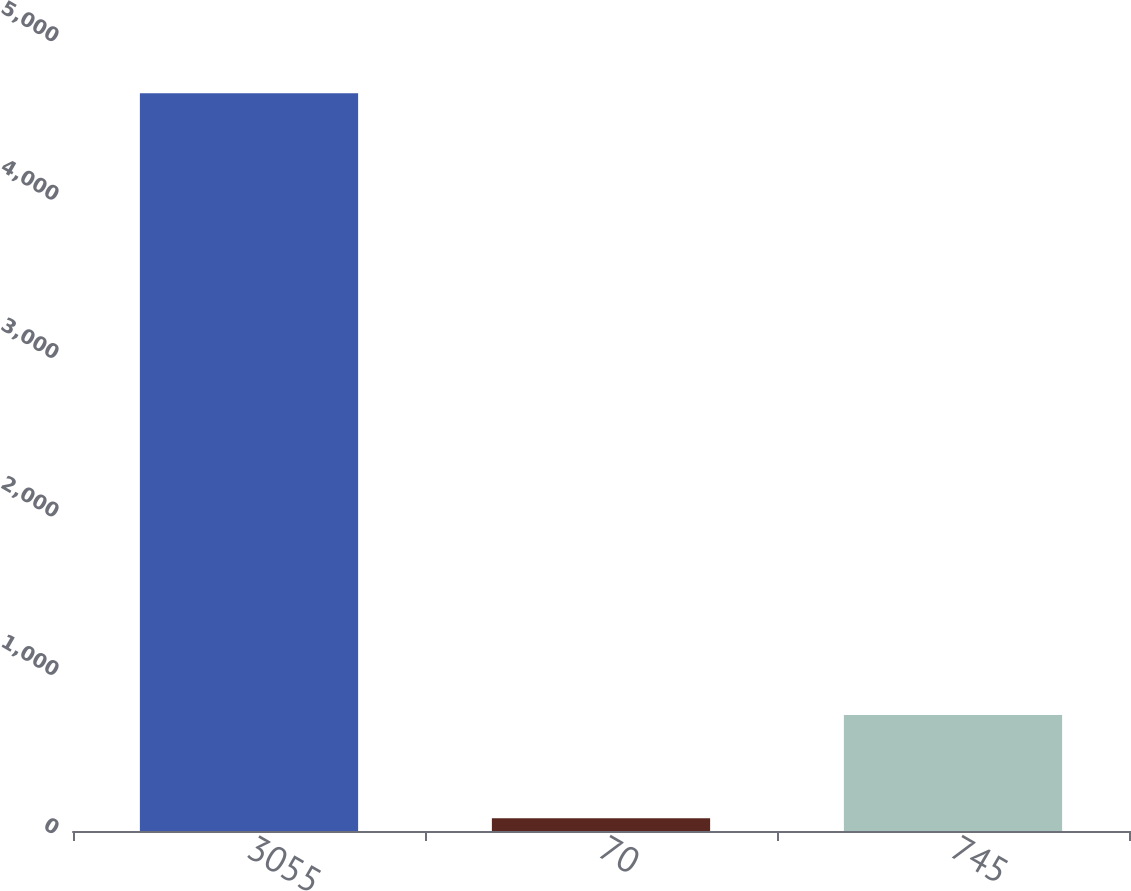Convert chart to OTSL. <chart><loc_0><loc_0><loc_500><loc_500><bar_chart><fcel>3055<fcel>70<fcel>745<nl><fcel>4658<fcel>80<fcel>733<nl></chart> 